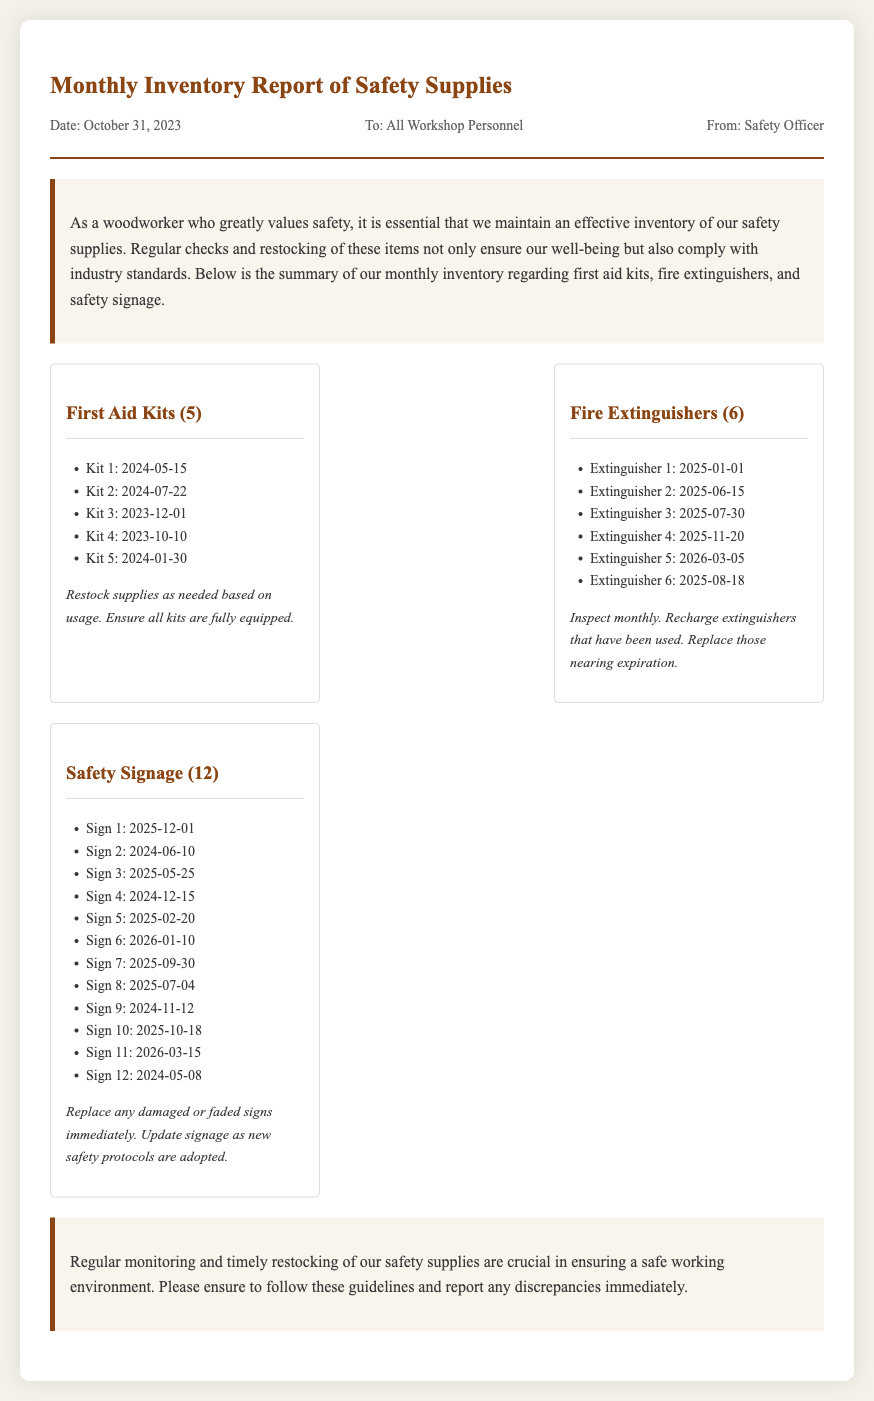what is the date of the report? The date of the report is mentioned at the top of the memo under the meta section.
Answer: October 31, 2023 how many first aid kits are listed? The number of first aid kits is specified in the heading of the first aid kits section.
Answer: 5 what is the expiration date of Kit 3? The expiration date for Kit 3 can be found in the list provided under first aid kits.
Answer: 2023-12-01 how many fire extinguishers are due for inspection based on the memo? The memo states there are 6 fire extinguishers that require monthly inspection.
Answer: 6 which safety signage needs immediate replacement? The memo specifies that damaged or faded signs must be replaced immediately, but does not list specific signs.
Answer: any damaged or faded signs when should Sign 2 be replaced? The expiration date of Sign 2 is provided in the safety signage expiration list.
Answer: 2024-06-10 how often should fire extinguishers be inspected? The memo outlines the inspection frequency for fire extinguishers in the restock section for extinguishers.
Answer: monthly what are the total types of safety supplies mentioned in the memo? The types of safety supplies are explicitly listed in their respective sections.
Answer: 3 (first aid kits, fire extinguishers, safety signage) 